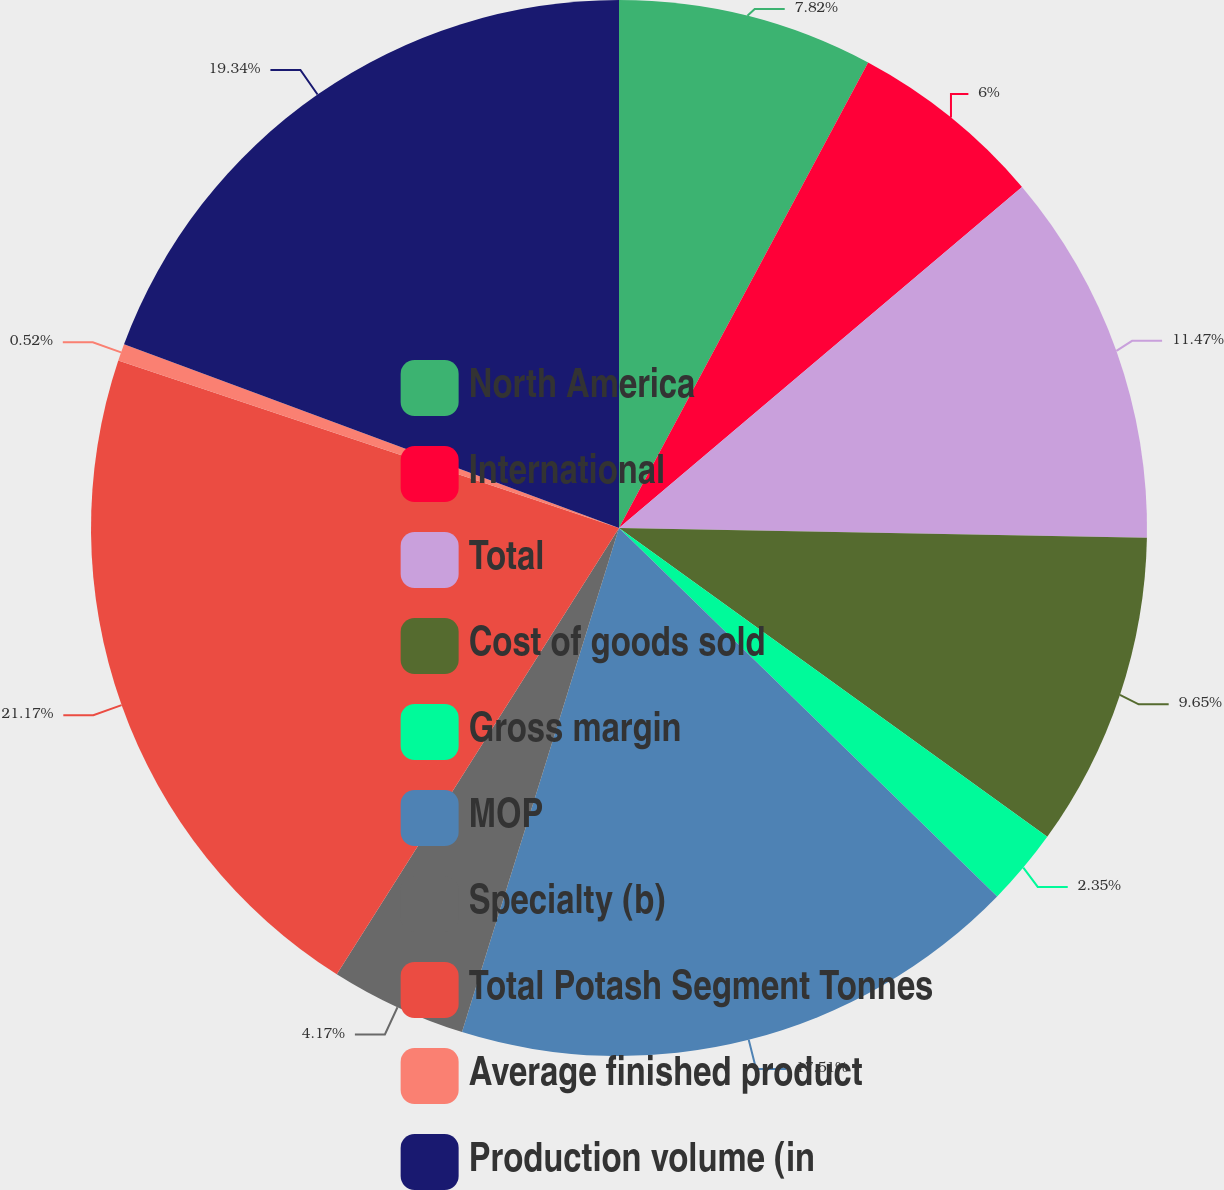Convert chart to OTSL. <chart><loc_0><loc_0><loc_500><loc_500><pie_chart><fcel>North America<fcel>International<fcel>Total<fcel>Cost of goods sold<fcel>Gross margin<fcel>MOP<fcel>Specialty (b)<fcel>Total Potash Segment Tonnes<fcel>Average finished product<fcel>Production volume (in<nl><fcel>7.82%<fcel>6.0%<fcel>11.47%<fcel>9.65%<fcel>2.35%<fcel>17.51%<fcel>4.17%<fcel>21.16%<fcel>0.52%<fcel>19.34%<nl></chart> 